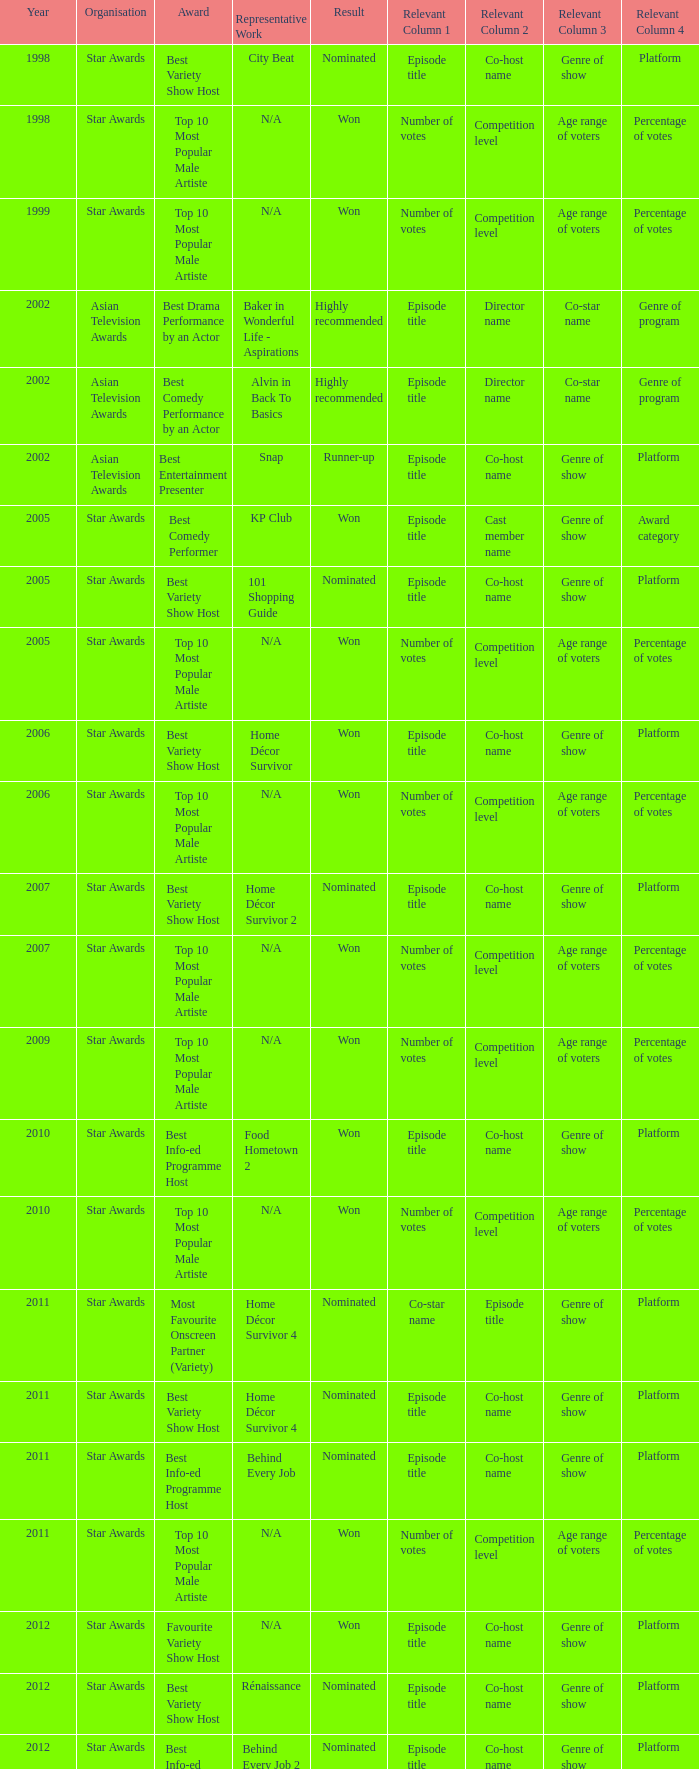What is the name of the Representative Work in a year later than 2005 with a Result of nominated, and an Award of best variety show host? Home Décor Survivor 2, Home Décor Survivor 4, Rénaissance, Jobs Around The World. 